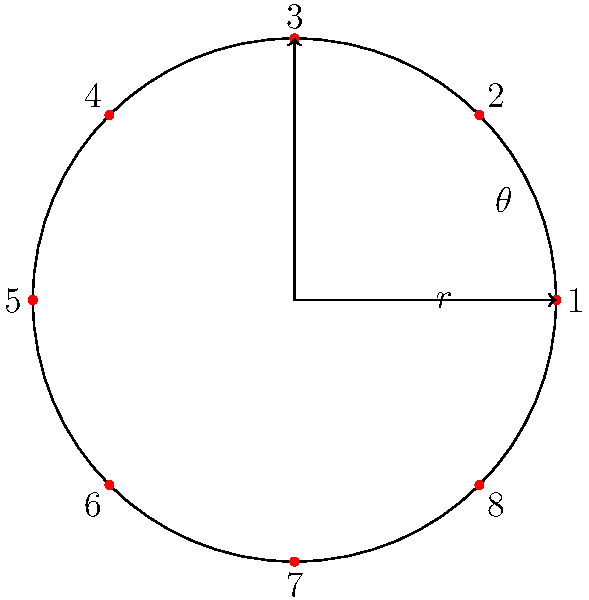In a circular theater with 8 equally spaced seats, you're designing a seating chart using polar coordinates. If seat 1 is at $(r, 0°)$ and the seats are numbered clockwise, what are the polar coordinates $(r, \theta)$ for seat 5? To find the polar coordinates of seat 5, we can follow these steps:

1. Understand the setup:
   - The theater has 8 equally spaced seats in a circular arrangement.
   - Seat 1 is at $(r, 0°)$, where $r$ is the radius of the circle.
   - The seats are numbered clockwise.

2. Calculate the angle between each seat:
   - Total angle of a circle = $360°$
   - Number of seats = 8
   - Angle between seats = $360° ÷ 8 = 45°$

3. Find the position of seat 5:
   - Seat 5 is 4 positions away from seat 1 in the clockwise direction.
   - Angle for seat 5 = $4 × 45° = 180°$

4. Express the result in polar coordinates:
   - The radius $r$ remains the same for all seats.
   - The angle $\theta$ for seat 5 is $180°$.

Therefore, the polar coordinates for seat 5 are $(r, 180°)$.
Answer: $(r, 180°)$ 